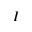<formula> <loc_0><loc_0><loc_500><loc_500>I</formula> 